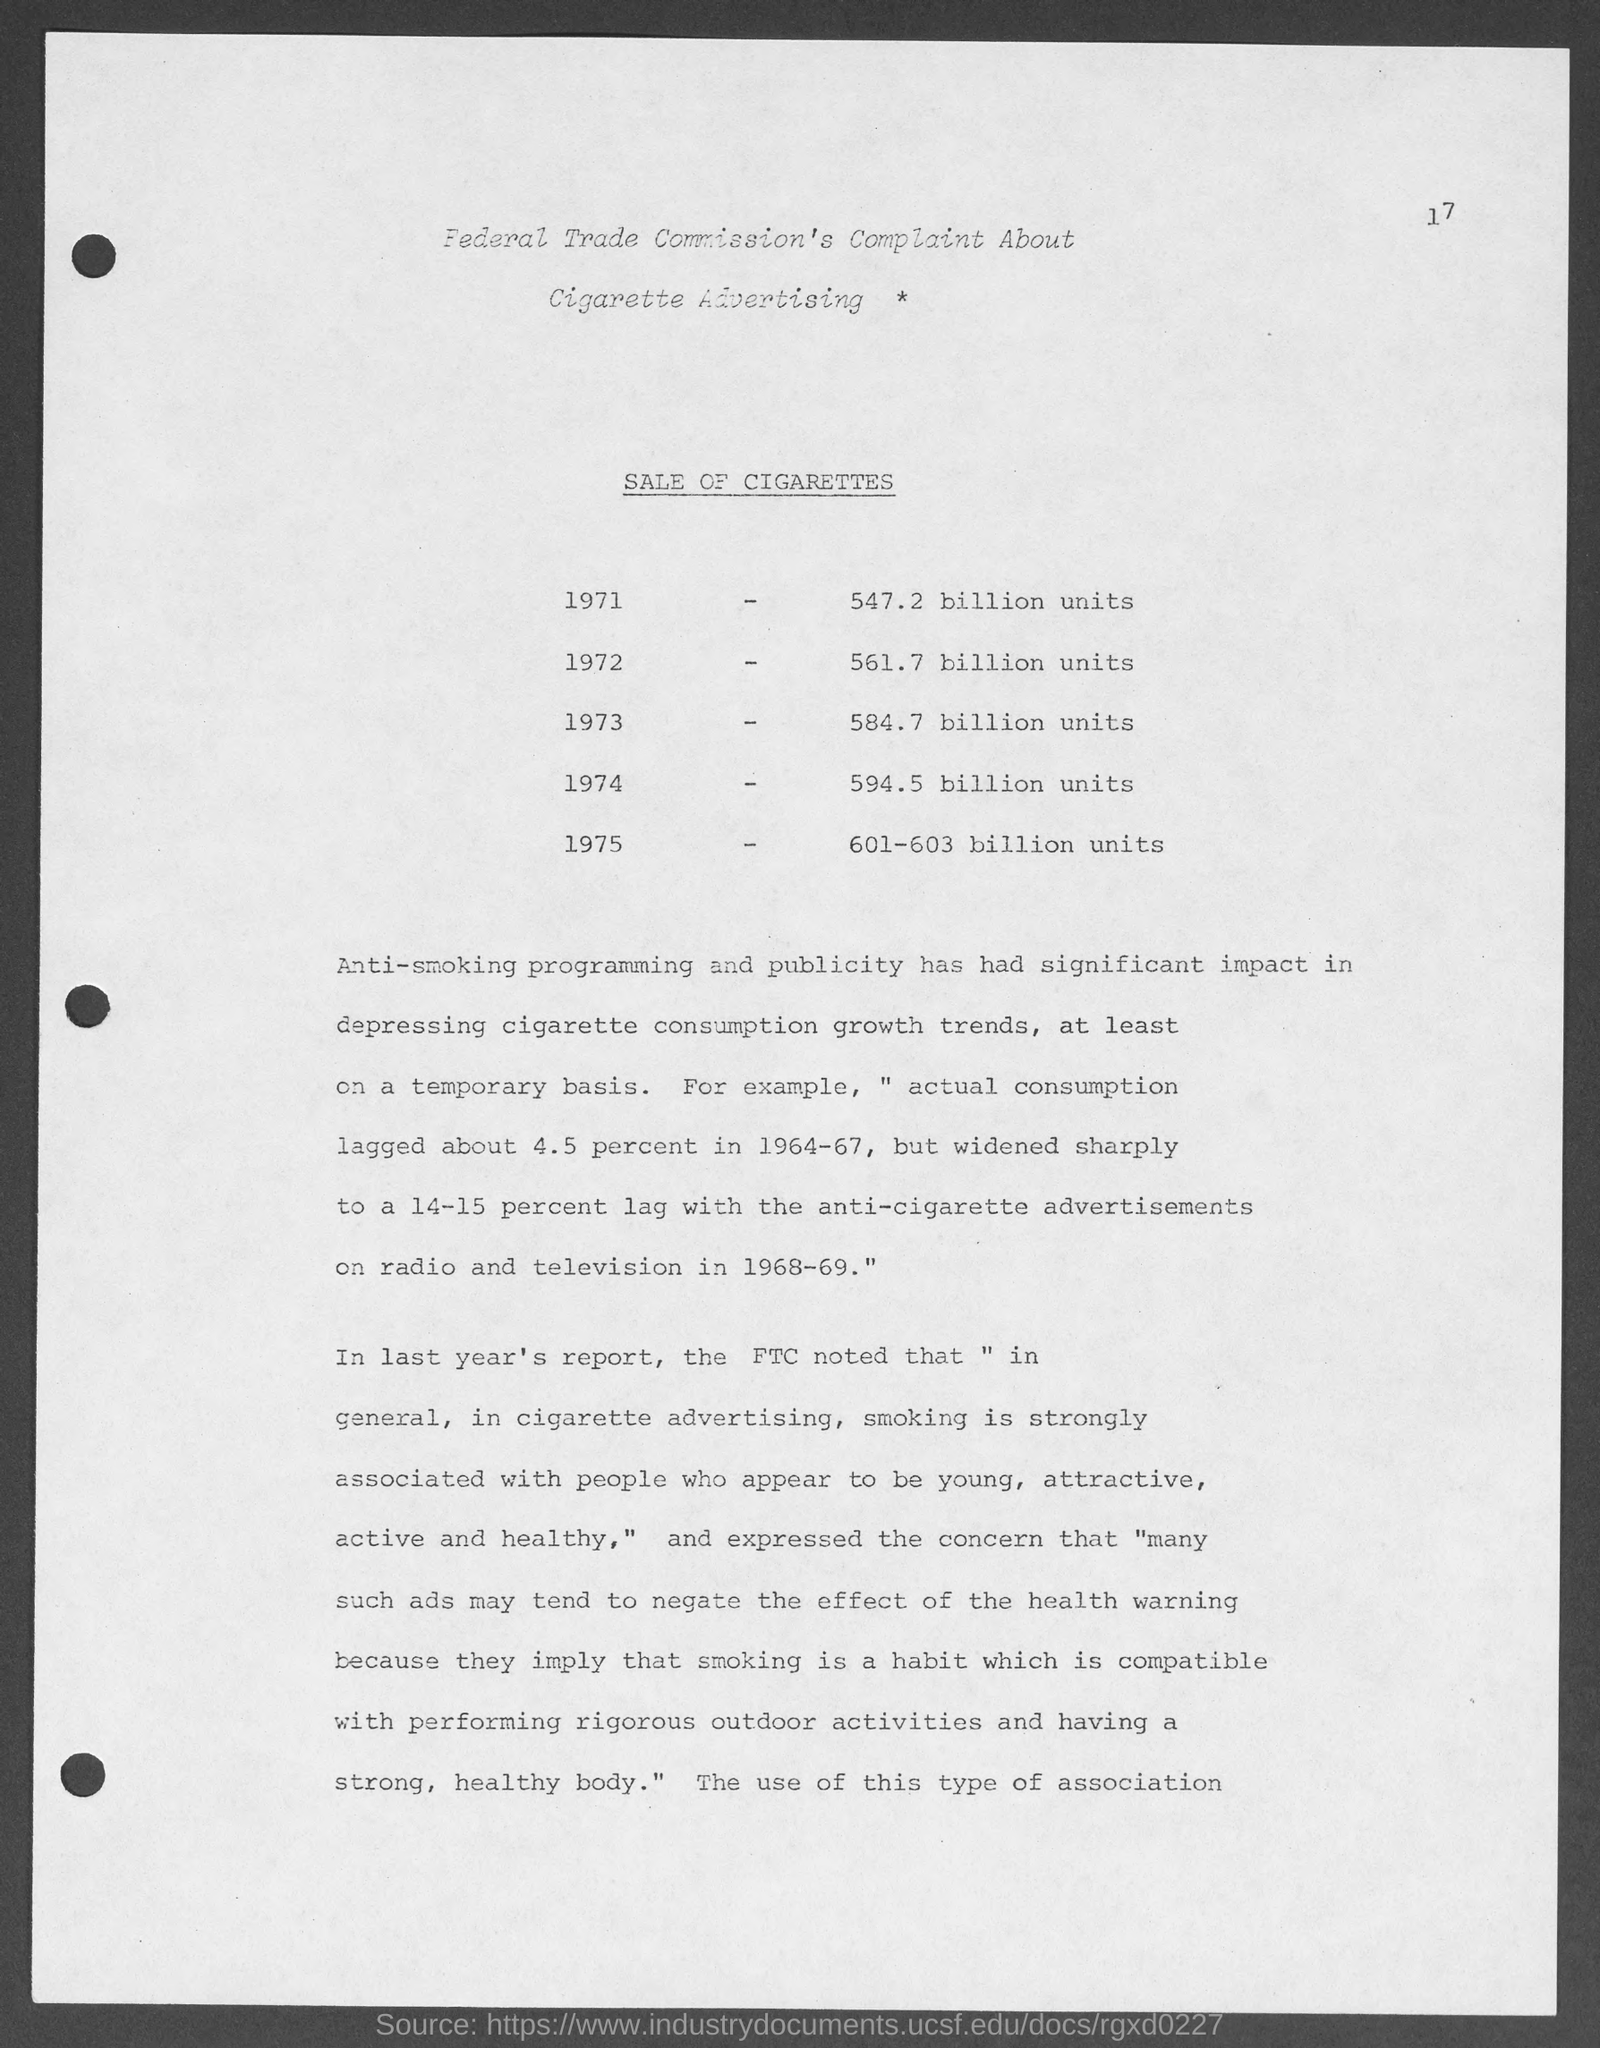What is the sale of cigarettes in the year 1971?
Your response must be concise. 547.2 BILLION UNITS. What is the sale of cigarettes in the year 1975?
Give a very brief answer. 601-603 billion units. In which year, the sale of cigarettes reached 561.7 billion units?
Your answer should be very brief. 1972. In which year, the sale of cigarettes reached 594.5 billion units?
Make the answer very short. 1974. 